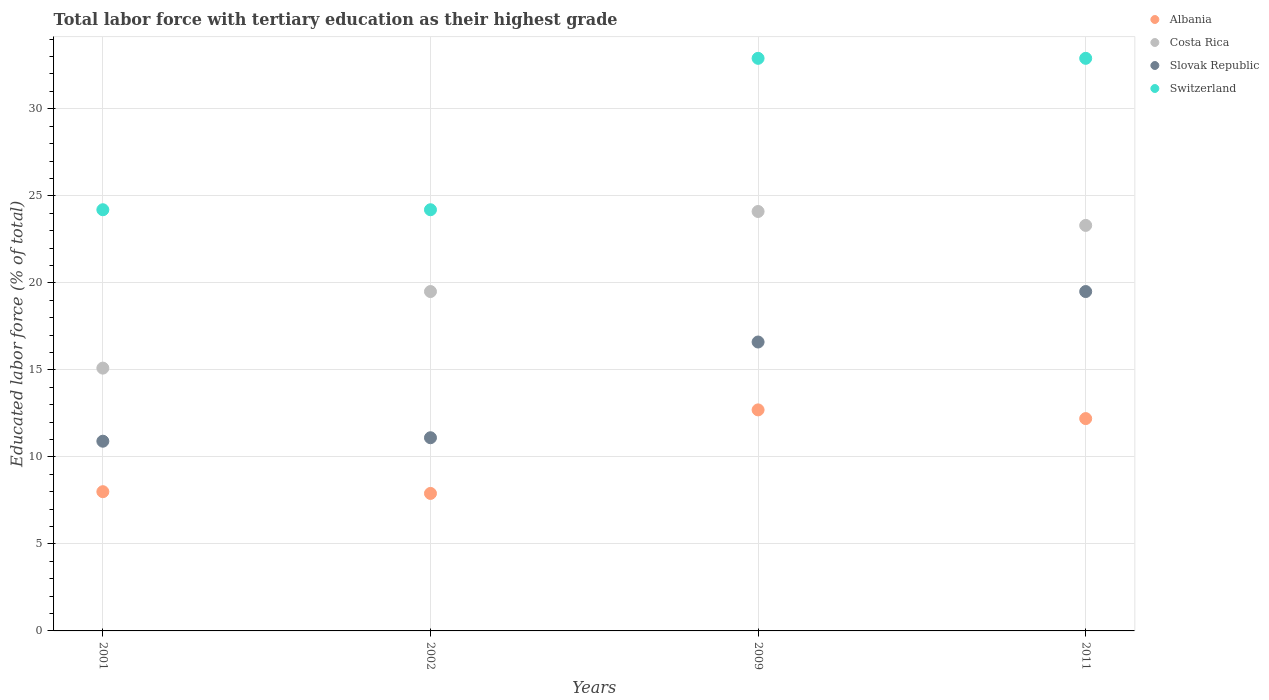How many different coloured dotlines are there?
Offer a terse response. 4. Is the number of dotlines equal to the number of legend labels?
Keep it short and to the point. Yes. What is the percentage of male labor force with tertiary education in Slovak Republic in 2001?
Make the answer very short. 10.9. Across all years, what is the maximum percentage of male labor force with tertiary education in Slovak Republic?
Provide a succinct answer. 19.5. Across all years, what is the minimum percentage of male labor force with tertiary education in Switzerland?
Provide a short and direct response. 24.2. In which year was the percentage of male labor force with tertiary education in Switzerland maximum?
Your answer should be compact. 2009. In which year was the percentage of male labor force with tertiary education in Slovak Republic minimum?
Make the answer very short. 2001. What is the total percentage of male labor force with tertiary education in Slovak Republic in the graph?
Give a very brief answer. 58.1. What is the difference between the percentage of male labor force with tertiary education in Albania in 2001 and that in 2011?
Your answer should be compact. -4.2. What is the difference between the percentage of male labor force with tertiary education in Costa Rica in 2011 and the percentage of male labor force with tertiary education in Albania in 2002?
Ensure brevity in your answer.  15.4. What is the average percentage of male labor force with tertiary education in Slovak Republic per year?
Ensure brevity in your answer.  14.53. In the year 2001, what is the difference between the percentage of male labor force with tertiary education in Slovak Republic and percentage of male labor force with tertiary education in Albania?
Ensure brevity in your answer.  2.9. What is the ratio of the percentage of male labor force with tertiary education in Slovak Republic in 2002 to that in 2009?
Ensure brevity in your answer.  0.67. Is the percentage of male labor force with tertiary education in Costa Rica in 2002 less than that in 2009?
Make the answer very short. Yes. What is the difference between the highest and the second highest percentage of male labor force with tertiary education in Slovak Republic?
Your answer should be very brief. 2.9. What is the difference between the highest and the lowest percentage of male labor force with tertiary education in Costa Rica?
Your answer should be very brief. 9. In how many years, is the percentage of male labor force with tertiary education in Slovak Republic greater than the average percentage of male labor force with tertiary education in Slovak Republic taken over all years?
Your answer should be compact. 2. Is it the case that in every year, the sum of the percentage of male labor force with tertiary education in Costa Rica and percentage of male labor force with tertiary education in Slovak Republic  is greater than the sum of percentage of male labor force with tertiary education in Albania and percentage of male labor force with tertiary education in Switzerland?
Offer a very short reply. Yes. Is it the case that in every year, the sum of the percentage of male labor force with tertiary education in Costa Rica and percentage of male labor force with tertiary education in Albania  is greater than the percentage of male labor force with tertiary education in Switzerland?
Offer a terse response. No. Is the percentage of male labor force with tertiary education in Albania strictly greater than the percentage of male labor force with tertiary education in Slovak Republic over the years?
Offer a terse response. No. How many dotlines are there?
Your answer should be very brief. 4. How many years are there in the graph?
Offer a terse response. 4. Are the values on the major ticks of Y-axis written in scientific E-notation?
Provide a succinct answer. No. Does the graph contain any zero values?
Provide a succinct answer. No. Does the graph contain grids?
Make the answer very short. Yes. Where does the legend appear in the graph?
Ensure brevity in your answer.  Top right. How many legend labels are there?
Ensure brevity in your answer.  4. What is the title of the graph?
Keep it short and to the point. Total labor force with tertiary education as their highest grade. Does "East Asia (developing only)" appear as one of the legend labels in the graph?
Your response must be concise. No. What is the label or title of the Y-axis?
Your answer should be compact. Educated labor force (% of total). What is the Educated labor force (% of total) of Albania in 2001?
Keep it short and to the point. 8. What is the Educated labor force (% of total) of Costa Rica in 2001?
Offer a terse response. 15.1. What is the Educated labor force (% of total) in Slovak Republic in 2001?
Offer a very short reply. 10.9. What is the Educated labor force (% of total) in Switzerland in 2001?
Ensure brevity in your answer.  24.2. What is the Educated labor force (% of total) in Albania in 2002?
Offer a very short reply. 7.9. What is the Educated labor force (% of total) of Costa Rica in 2002?
Give a very brief answer. 19.5. What is the Educated labor force (% of total) of Slovak Republic in 2002?
Provide a short and direct response. 11.1. What is the Educated labor force (% of total) of Switzerland in 2002?
Your answer should be compact. 24.2. What is the Educated labor force (% of total) in Albania in 2009?
Keep it short and to the point. 12.7. What is the Educated labor force (% of total) in Costa Rica in 2009?
Provide a succinct answer. 24.1. What is the Educated labor force (% of total) in Slovak Republic in 2009?
Give a very brief answer. 16.6. What is the Educated labor force (% of total) in Switzerland in 2009?
Your answer should be very brief. 32.9. What is the Educated labor force (% of total) in Albania in 2011?
Your answer should be compact. 12.2. What is the Educated labor force (% of total) in Costa Rica in 2011?
Provide a short and direct response. 23.3. What is the Educated labor force (% of total) of Slovak Republic in 2011?
Ensure brevity in your answer.  19.5. What is the Educated labor force (% of total) in Switzerland in 2011?
Ensure brevity in your answer.  32.9. Across all years, what is the maximum Educated labor force (% of total) of Albania?
Your answer should be very brief. 12.7. Across all years, what is the maximum Educated labor force (% of total) in Costa Rica?
Make the answer very short. 24.1. Across all years, what is the maximum Educated labor force (% of total) of Switzerland?
Ensure brevity in your answer.  32.9. Across all years, what is the minimum Educated labor force (% of total) of Albania?
Your response must be concise. 7.9. Across all years, what is the minimum Educated labor force (% of total) of Costa Rica?
Make the answer very short. 15.1. Across all years, what is the minimum Educated labor force (% of total) in Slovak Republic?
Provide a short and direct response. 10.9. Across all years, what is the minimum Educated labor force (% of total) of Switzerland?
Your answer should be very brief. 24.2. What is the total Educated labor force (% of total) of Albania in the graph?
Offer a very short reply. 40.8. What is the total Educated labor force (% of total) of Costa Rica in the graph?
Give a very brief answer. 82. What is the total Educated labor force (% of total) of Slovak Republic in the graph?
Provide a succinct answer. 58.1. What is the total Educated labor force (% of total) in Switzerland in the graph?
Offer a terse response. 114.2. What is the difference between the Educated labor force (% of total) in Slovak Republic in 2001 and that in 2002?
Ensure brevity in your answer.  -0.2. What is the difference between the Educated labor force (% of total) of Switzerland in 2001 and that in 2002?
Offer a very short reply. 0. What is the difference between the Educated labor force (% of total) of Slovak Republic in 2001 and that in 2009?
Keep it short and to the point. -5.7. What is the difference between the Educated labor force (% of total) in Costa Rica in 2001 and that in 2011?
Offer a very short reply. -8.2. What is the difference between the Educated labor force (% of total) in Switzerland in 2001 and that in 2011?
Offer a terse response. -8.7. What is the difference between the Educated labor force (% of total) in Albania in 2002 and that in 2009?
Offer a terse response. -4.8. What is the difference between the Educated labor force (% of total) of Switzerland in 2002 and that in 2009?
Offer a terse response. -8.7. What is the difference between the Educated labor force (% of total) in Albania in 2002 and that in 2011?
Keep it short and to the point. -4.3. What is the difference between the Educated labor force (% of total) of Costa Rica in 2002 and that in 2011?
Provide a short and direct response. -3.8. What is the difference between the Educated labor force (% of total) of Switzerland in 2002 and that in 2011?
Your answer should be compact. -8.7. What is the difference between the Educated labor force (% of total) in Costa Rica in 2009 and that in 2011?
Your response must be concise. 0.8. What is the difference between the Educated labor force (% of total) in Slovak Republic in 2009 and that in 2011?
Offer a terse response. -2.9. What is the difference between the Educated labor force (% of total) in Albania in 2001 and the Educated labor force (% of total) in Costa Rica in 2002?
Provide a short and direct response. -11.5. What is the difference between the Educated labor force (% of total) in Albania in 2001 and the Educated labor force (% of total) in Switzerland in 2002?
Ensure brevity in your answer.  -16.2. What is the difference between the Educated labor force (% of total) in Slovak Republic in 2001 and the Educated labor force (% of total) in Switzerland in 2002?
Provide a short and direct response. -13.3. What is the difference between the Educated labor force (% of total) in Albania in 2001 and the Educated labor force (% of total) in Costa Rica in 2009?
Your answer should be compact. -16.1. What is the difference between the Educated labor force (% of total) in Albania in 2001 and the Educated labor force (% of total) in Switzerland in 2009?
Ensure brevity in your answer.  -24.9. What is the difference between the Educated labor force (% of total) in Costa Rica in 2001 and the Educated labor force (% of total) in Switzerland in 2009?
Offer a very short reply. -17.8. What is the difference between the Educated labor force (% of total) of Slovak Republic in 2001 and the Educated labor force (% of total) of Switzerland in 2009?
Your answer should be compact. -22. What is the difference between the Educated labor force (% of total) of Albania in 2001 and the Educated labor force (% of total) of Costa Rica in 2011?
Offer a terse response. -15.3. What is the difference between the Educated labor force (% of total) in Albania in 2001 and the Educated labor force (% of total) in Slovak Republic in 2011?
Ensure brevity in your answer.  -11.5. What is the difference between the Educated labor force (% of total) of Albania in 2001 and the Educated labor force (% of total) of Switzerland in 2011?
Your answer should be very brief. -24.9. What is the difference between the Educated labor force (% of total) of Costa Rica in 2001 and the Educated labor force (% of total) of Switzerland in 2011?
Give a very brief answer. -17.8. What is the difference between the Educated labor force (% of total) of Albania in 2002 and the Educated labor force (% of total) of Costa Rica in 2009?
Provide a succinct answer. -16.2. What is the difference between the Educated labor force (% of total) in Costa Rica in 2002 and the Educated labor force (% of total) in Switzerland in 2009?
Keep it short and to the point. -13.4. What is the difference between the Educated labor force (% of total) in Slovak Republic in 2002 and the Educated labor force (% of total) in Switzerland in 2009?
Make the answer very short. -21.8. What is the difference between the Educated labor force (% of total) of Albania in 2002 and the Educated labor force (% of total) of Costa Rica in 2011?
Provide a short and direct response. -15.4. What is the difference between the Educated labor force (% of total) of Albania in 2002 and the Educated labor force (% of total) of Switzerland in 2011?
Give a very brief answer. -25. What is the difference between the Educated labor force (% of total) in Costa Rica in 2002 and the Educated labor force (% of total) in Switzerland in 2011?
Ensure brevity in your answer.  -13.4. What is the difference between the Educated labor force (% of total) of Slovak Republic in 2002 and the Educated labor force (% of total) of Switzerland in 2011?
Make the answer very short. -21.8. What is the difference between the Educated labor force (% of total) in Albania in 2009 and the Educated labor force (% of total) in Slovak Republic in 2011?
Provide a succinct answer. -6.8. What is the difference between the Educated labor force (% of total) of Albania in 2009 and the Educated labor force (% of total) of Switzerland in 2011?
Make the answer very short. -20.2. What is the difference between the Educated labor force (% of total) in Slovak Republic in 2009 and the Educated labor force (% of total) in Switzerland in 2011?
Your answer should be compact. -16.3. What is the average Educated labor force (% of total) in Costa Rica per year?
Keep it short and to the point. 20.5. What is the average Educated labor force (% of total) in Slovak Republic per year?
Ensure brevity in your answer.  14.53. What is the average Educated labor force (% of total) in Switzerland per year?
Your answer should be compact. 28.55. In the year 2001, what is the difference between the Educated labor force (% of total) of Albania and Educated labor force (% of total) of Costa Rica?
Your answer should be compact. -7.1. In the year 2001, what is the difference between the Educated labor force (% of total) in Albania and Educated labor force (% of total) in Slovak Republic?
Your response must be concise. -2.9. In the year 2001, what is the difference between the Educated labor force (% of total) of Albania and Educated labor force (% of total) of Switzerland?
Make the answer very short. -16.2. In the year 2001, what is the difference between the Educated labor force (% of total) of Costa Rica and Educated labor force (% of total) of Slovak Republic?
Give a very brief answer. 4.2. In the year 2002, what is the difference between the Educated labor force (% of total) of Albania and Educated labor force (% of total) of Costa Rica?
Provide a succinct answer. -11.6. In the year 2002, what is the difference between the Educated labor force (% of total) in Albania and Educated labor force (% of total) in Slovak Republic?
Make the answer very short. -3.2. In the year 2002, what is the difference between the Educated labor force (% of total) of Albania and Educated labor force (% of total) of Switzerland?
Your answer should be very brief. -16.3. In the year 2002, what is the difference between the Educated labor force (% of total) of Costa Rica and Educated labor force (% of total) of Slovak Republic?
Your response must be concise. 8.4. In the year 2002, what is the difference between the Educated labor force (% of total) of Costa Rica and Educated labor force (% of total) of Switzerland?
Give a very brief answer. -4.7. In the year 2009, what is the difference between the Educated labor force (% of total) of Albania and Educated labor force (% of total) of Slovak Republic?
Provide a short and direct response. -3.9. In the year 2009, what is the difference between the Educated labor force (% of total) of Albania and Educated labor force (% of total) of Switzerland?
Provide a succinct answer. -20.2. In the year 2009, what is the difference between the Educated labor force (% of total) of Slovak Republic and Educated labor force (% of total) of Switzerland?
Your answer should be compact. -16.3. In the year 2011, what is the difference between the Educated labor force (% of total) of Albania and Educated labor force (% of total) of Costa Rica?
Offer a very short reply. -11.1. In the year 2011, what is the difference between the Educated labor force (% of total) in Albania and Educated labor force (% of total) in Switzerland?
Make the answer very short. -20.7. In the year 2011, what is the difference between the Educated labor force (% of total) of Costa Rica and Educated labor force (% of total) of Slovak Republic?
Provide a succinct answer. 3.8. In the year 2011, what is the difference between the Educated labor force (% of total) of Costa Rica and Educated labor force (% of total) of Switzerland?
Your answer should be compact. -9.6. In the year 2011, what is the difference between the Educated labor force (% of total) of Slovak Republic and Educated labor force (% of total) of Switzerland?
Offer a very short reply. -13.4. What is the ratio of the Educated labor force (% of total) in Albania in 2001 to that in 2002?
Give a very brief answer. 1.01. What is the ratio of the Educated labor force (% of total) of Costa Rica in 2001 to that in 2002?
Provide a short and direct response. 0.77. What is the ratio of the Educated labor force (% of total) in Switzerland in 2001 to that in 2002?
Your answer should be very brief. 1. What is the ratio of the Educated labor force (% of total) in Albania in 2001 to that in 2009?
Offer a terse response. 0.63. What is the ratio of the Educated labor force (% of total) in Costa Rica in 2001 to that in 2009?
Your response must be concise. 0.63. What is the ratio of the Educated labor force (% of total) of Slovak Republic in 2001 to that in 2009?
Give a very brief answer. 0.66. What is the ratio of the Educated labor force (% of total) of Switzerland in 2001 to that in 2009?
Ensure brevity in your answer.  0.74. What is the ratio of the Educated labor force (% of total) of Albania in 2001 to that in 2011?
Your answer should be compact. 0.66. What is the ratio of the Educated labor force (% of total) of Costa Rica in 2001 to that in 2011?
Your response must be concise. 0.65. What is the ratio of the Educated labor force (% of total) in Slovak Republic in 2001 to that in 2011?
Your response must be concise. 0.56. What is the ratio of the Educated labor force (% of total) of Switzerland in 2001 to that in 2011?
Make the answer very short. 0.74. What is the ratio of the Educated labor force (% of total) of Albania in 2002 to that in 2009?
Give a very brief answer. 0.62. What is the ratio of the Educated labor force (% of total) of Costa Rica in 2002 to that in 2009?
Make the answer very short. 0.81. What is the ratio of the Educated labor force (% of total) in Slovak Republic in 2002 to that in 2009?
Make the answer very short. 0.67. What is the ratio of the Educated labor force (% of total) in Switzerland in 2002 to that in 2009?
Provide a short and direct response. 0.74. What is the ratio of the Educated labor force (% of total) of Albania in 2002 to that in 2011?
Offer a terse response. 0.65. What is the ratio of the Educated labor force (% of total) of Costa Rica in 2002 to that in 2011?
Keep it short and to the point. 0.84. What is the ratio of the Educated labor force (% of total) in Slovak Republic in 2002 to that in 2011?
Your answer should be compact. 0.57. What is the ratio of the Educated labor force (% of total) in Switzerland in 2002 to that in 2011?
Offer a very short reply. 0.74. What is the ratio of the Educated labor force (% of total) in Albania in 2009 to that in 2011?
Your answer should be compact. 1.04. What is the ratio of the Educated labor force (% of total) in Costa Rica in 2009 to that in 2011?
Ensure brevity in your answer.  1.03. What is the ratio of the Educated labor force (% of total) in Slovak Republic in 2009 to that in 2011?
Provide a succinct answer. 0.85. What is the ratio of the Educated labor force (% of total) in Switzerland in 2009 to that in 2011?
Keep it short and to the point. 1. What is the difference between the highest and the second highest Educated labor force (% of total) in Slovak Republic?
Provide a succinct answer. 2.9. What is the difference between the highest and the lowest Educated labor force (% of total) of Albania?
Your answer should be very brief. 4.8. What is the difference between the highest and the lowest Educated labor force (% of total) in Costa Rica?
Give a very brief answer. 9. What is the difference between the highest and the lowest Educated labor force (% of total) of Slovak Republic?
Offer a terse response. 8.6. What is the difference between the highest and the lowest Educated labor force (% of total) of Switzerland?
Ensure brevity in your answer.  8.7. 